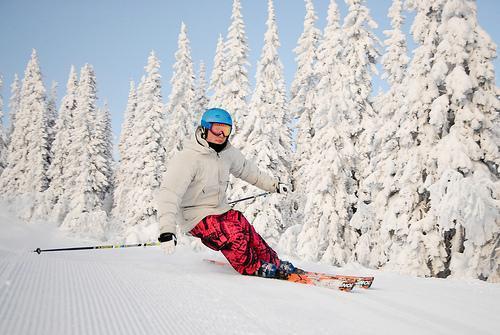How many people are in the picture?
Give a very brief answer. 1. 